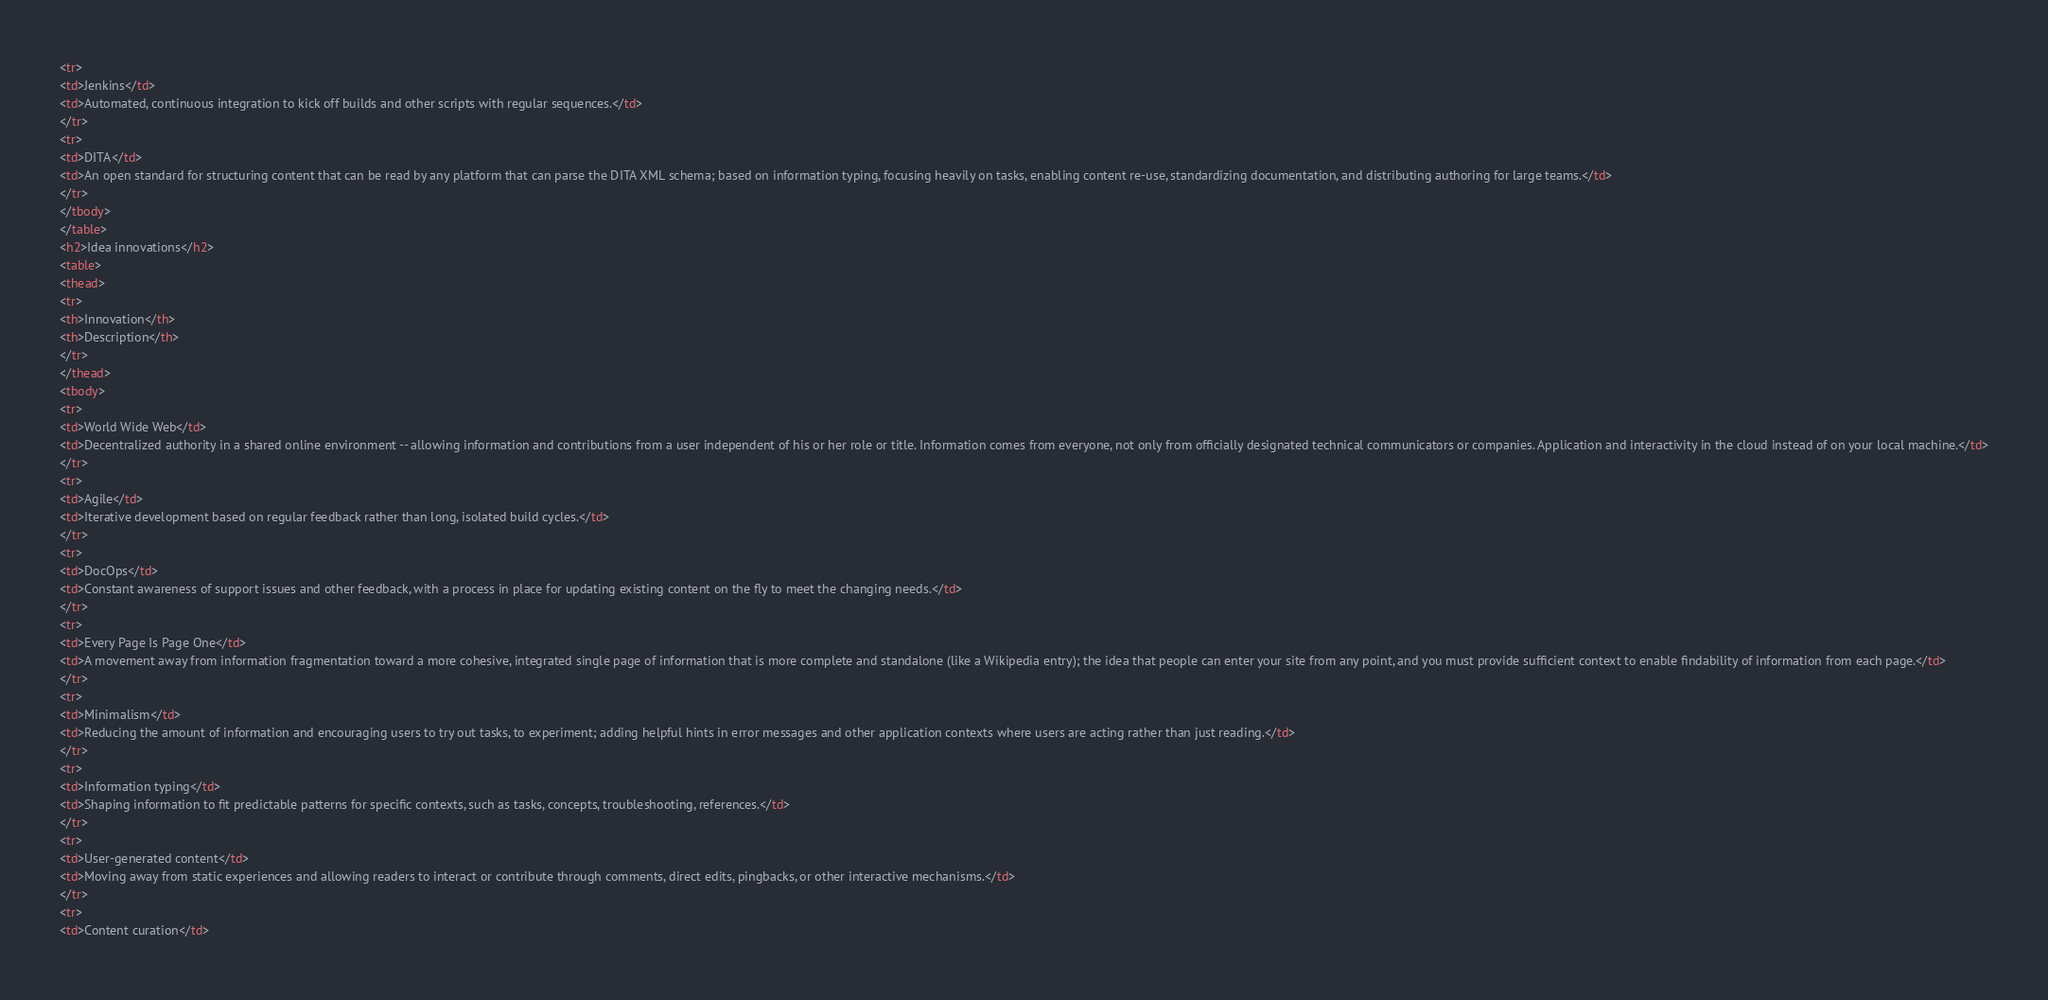Convert code to text. <code><loc_0><loc_0><loc_500><loc_500><_HTML_><tr>
<td>Jenkins</td>
<td>Automated, continuous integration to kick off builds and other scripts with regular sequences.</td>
</tr>
<tr>
<td>DITA</td>
<td>An open standard for structuring content that can be read by any platform that can parse the DITA XML schema; based on information typing, focusing heavily on tasks, enabling content re-use, standardizing documentation, and distributing authoring for large teams.</td>
</tr>
</tbody>
</table>
<h2>Idea innovations</h2>
<table>
<thead>
<tr>
<th>Innovation</th>
<th>Description</th>
</tr>
</thead>
<tbody>
<tr>
<td>World Wide Web</td>
<td>Decentralized authority in a shared online environment -- allowing information and contributions from a user independent of his or her role or title. Information comes from everyone, not only from officially designated technical communicators or companies. Application and interactivity in the cloud instead of on your local machine.</td>
</tr>
<tr>
<td>Agile</td>
<td>Iterative development based on regular feedback rather than long, isolated build cycles.</td>
</tr>
<tr>
<td>DocOps</td>
<td>Constant awareness of support issues and other feedback, with a process in place for updating existing content on the fly to meet the changing needs.</td>
</tr>
<tr>
<td>Every Page Is Page One</td>
<td>A movement away from information fragmentation toward a more cohesive, integrated single page of information that is more complete and standalone (like a Wikipedia entry); the idea that people can enter your site from any point, and you must provide sufficient context to enable findability of information from each page.</td>
</tr>
<tr>
<td>Minimalism</td>
<td>Reducing the amount of information and encouraging users to try out tasks, to experiment; adding helpful hints in error messages and other application contexts where users are acting rather than just reading.</td>
</tr>
<tr>
<td>Information typing</td>
<td>Shaping information to fit predictable patterns for specific contexts, such as tasks, concepts, troubleshooting, references.</td>
</tr>
<tr>
<td>User-generated content</td>
<td>Moving away from static experiences and allowing readers to interact or contribute through comments, direct edits, pingbacks, or other interactive mechanisms.</td>
</tr>
<tr>
<td>Content curation</td></code> 